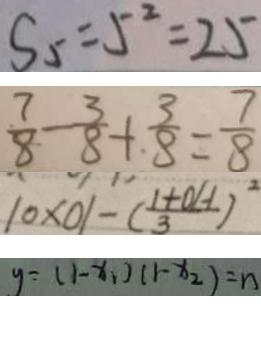<formula> <loc_0><loc_0><loc_500><loc_500>S _ { 5 } = 5 ^ { 2 } = 2 5 
 \frac { 7 } { 8 } - \frac { 3 } { 8 } + \frac { 3 } { 8 } = \frac { 7 } { 8 } 
 1 0 \times 0 1 - ( \frac { 1 + 0 H } { 3 } ) ^ { 2 } 
 y = ( 1 - x _ { 1 } ) ( 1 - x _ { 2 } ) = n</formula> 